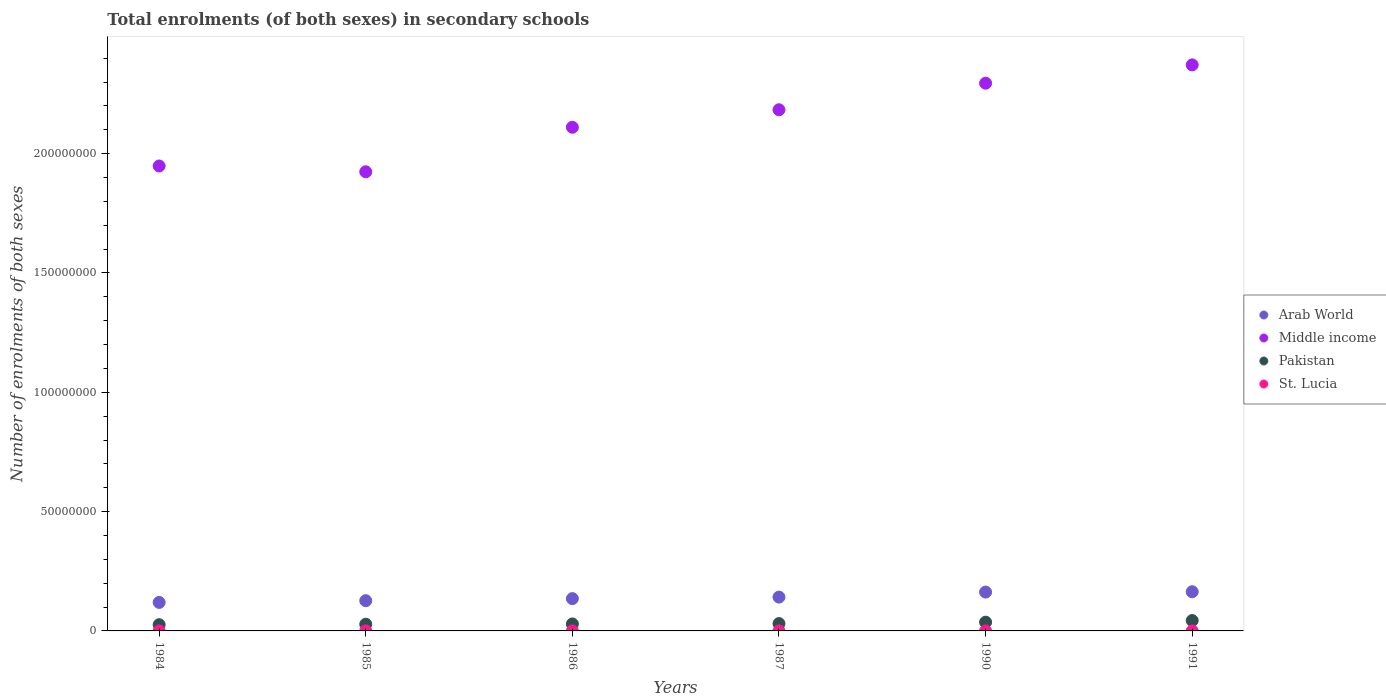What is the number of enrolments in secondary schools in Middle income in 1987?
Give a very brief answer. 2.18e+08. Across all years, what is the maximum number of enrolments in secondary schools in St. Lucia?
Give a very brief answer. 8230. Across all years, what is the minimum number of enrolments in secondary schools in St. Lucia?
Keep it short and to the point. 5205. In which year was the number of enrolments in secondary schools in St. Lucia minimum?
Offer a very short reply. 1984. What is the total number of enrolments in secondary schools in Pakistan in the graph?
Provide a succinct answer. 1.94e+07. What is the difference between the number of enrolments in secondary schools in Arab World in 1984 and that in 1991?
Make the answer very short. -4.48e+06. What is the difference between the number of enrolments in secondary schools in Middle income in 1985 and the number of enrolments in secondary schools in Arab World in 1986?
Your answer should be compact. 1.79e+08. What is the average number of enrolments in secondary schools in Arab World per year?
Your answer should be compact. 1.42e+07. In the year 1985, what is the difference between the number of enrolments in secondary schools in Arab World and number of enrolments in secondary schools in St. Lucia?
Your response must be concise. 1.27e+07. In how many years, is the number of enrolments in secondary schools in Pakistan greater than 90000000?
Give a very brief answer. 0. What is the ratio of the number of enrolments in secondary schools in Arab World in 1984 to that in 1986?
Keep it short and to the point. 0.88. What is the difference between the highest and the second highest number of enrolments in secondary schools in St. Lucia?
Offer a terse response. 428. What is the difference between the highest and the lowest number of enrolments in secondary schools in Middle income?
Your answer should be very brief. 4.48e+07. Is the number of enrolments in secondary schools in Middle income strictly less than the number of enrolments in secondary schools in Pakistan over the years?
Provide a short and direct response. No. How many dotlines are there?
Your answer should be very brief. 4. Are the values on the major ticks of Y-axis written in scientific E-notation?
Your answer should be very brief. No. Does the graph contain grids?
Ensure brevity in your answer.  No. Where does the legend appear in the graph?
Ensure brevity in your answer.  Center right. How many legend labels are there?
Provide a succinct answer. 4. What is the title of the graph?
Your answer should be compact. Total enrolments (of both sexes) in secondary schools. Does "Burkina Faso" appear as one of the legend labels in the graph?
Make the answer very short. No. What is the label or title of the X-axis?
Provide a short and direct response. Years. What is the label or title of the Y-axis?
Make the answer very short. Number of enrolments of both sexes. What is the Number of enrolments of both sexes in Arab World in 1984?
Provide a succinct answer. 1.19e+07. What is the Number of enrolments of both sexes of Middle income in 1984?
Provide a succinct answer. 1.95e+08. What is the Number of enrolments of both sexes of Pakistan in 1984?
Your response must be concise. 2.62e+06. What is the Number of enrolments of both sexes of St. Lucia in 1984?
Offer a very short reply. 5205. What is the Number of enrolments of both sexes of Arab World in 1985?
Provide a short and direct response. 1.27e+07. What is the Number of enrolments of both sexes of Middle income in 1985?
Offer a very short reply. 1.92e+08. What is the Number of enrolments of both sexes of Pakistan in 1985?
Offer a very short reply. 2.81e+06. What is the Number of enrolments of both sexes in St. Lucia in 1985?
Your answer should be very brief. 6212. What is the Number of enrolments of both sexes of Arab World in 1986?
Offer a terse response. 1.35e+07. What is the Number of enrolments of both sexes of Middle income in 1986?
Ensure brevity in your answer.  2.11e+08. What is the Number of enrolments of both sexes in Pakistan in 1986?
Your response must be concise. 2.92e+06. What is the Number of enrolments of both sexes of St. Lucia in 1986?
Ensure brevity in your answer.  6833. What is the Number of enrolments of both sexes in Arab World in 1987?
Make the answer very short. 1.42e+07. What is the Number of enrolments of both sexes of Middle income in 1987?
Keep it short and to the point. 2.18e+08. What is the Number of enrolments of both sexes in Pakistan in 1987?
Offer a very short reply. 3.07e+06. What is the Number of enrolments of both sexes of St. Lucia in 1987?
Your answer should be very brief. 7013. What is the Number of enrolments of both sexes of Arab World in 1990?
Offer a very short reply. 1.63e+07. What is the Number of enrolments of both sexes in Middle income in 1990?
Provide a short and direct response. 2.30e+08. What is the Number of enrolments of both sexes in Pakistan in 1990?
Give a very brief answer. 3.67e+06. What is the Number of enrolments of both sexes of St. Lucia in 1990?
Your answer should be very brief. 7802. What is the Number of enrolments of both sexes of Arab World in 1991?
Provide a succinct answer. 1.64e+07. What is the Number of enrolments of both sexes of Middle income in 1991?
Your answer should be compact. 2.37e+08. What is the Number of enrolments of both sexes of Pakistan in 1991?
Keep it short and to the point. 4.35e+06. What is the Number of enrolments of both sexes of St. Lucia in 1991?
Provide a succinct answer. 8230. Across all years, what is the maximum Number of enrolments of both sexes in Arab World?
Offer a terse response. 1.64e+07. Across all years, what is the maximum Number of enrolments of both sexes in Middle income?
Your answer should be very brief. 2.37e+08. Across all years, what is the maximum Number of enrolments of both sexes of Pakistan?
Your answer should be very brief. 4.35e+06. Across all years, what is the maximum Number of enrolments of both sexes in St. Lucia?
Your answer should be compact. 8230. Across all years, what is the minimum Number of enrolments of both sexes in Arab World?
Provide a short and direct response. 1.19e+07. Across all years, what is the minimum Number of enrolments of both sexes of Middle income?
Offer a very short reply. 1.92e+08. Across all years, what is the minimum Number of enrolments of both sexes of Pakistan?
Offer a very short reply. 2.62e+06. Across all years, what is the minimum Number of enrolments of both sexes of St. Lucia?
Provide a short and direct response. 5205. What is the total Number of enrolments of both sexes of Arab World in the graph?
Your answer should be very brief. 8.50e+07. What is the total Number of enrolments of both sexes of Middle income in the graph?
Give a very brief answer. 1.28e+09. What is the total Number of enrolments of both sexes of Pakistan in the graph?
Your answer should be very brief. 1.94e+07. What is the total Number of enrolments of both sexes of St. Lucia in the graph?
Offer a very short reply. 4.13e+04. What is the difference between the Number of enrolments of both sexes in Arab World in 1984 and that in 1985?
Your answer should be very brief. -7.28e+05. What is the difference between the Number of enrolments of both sexes in Middle income in 1984 and that in 1985?
Offer a very short reply. 2.43e+06. What is the difference between the Number of enrolments of both sexes in Pakistan in 1984 and that in 1985?
Provide a short and direct response. -1.96e+05. What is the difference between the Number of enrolments of both sexes in St. Lucia in 1984 and that in 1985?
Offer a very short reply. -1007. What is the difference between the Number of enrolments of both sexes in Arab World in 1984 and that in 1986?
Provide a succinct answer. -1.59e+06. What is the difference between the Number of enrolments of both sexes in Middle income in 1984 and that in 1986?
Keep it short and to the point. -1.62e+07. What is the difference between the Number of enrolments of both sexes in Pakistan in 1984 and that in 1986?
Ensure brevity in your answer.  -3.08e+05. What is the difference between the Number of enrolments of both sexes of St. Lucia in 1984 and that in 1986?
Offer a very short reply. -1628. What is the difference between the Number of enrolments of both sexes in Arab World in 1984 and that in 1987?
Keep it short and to the point. -2.23e+06. What is the difference between the Number of enrolments of both sexes of Middle income in 1984 and that in 1987?
Ensure brevity in your answer.  -2.36e+07. What is the difference between the Number of enrolments of both sexes in Pakistan in 1984 and that in 1987?
Your response must be concise. -4.56e+05. What is the difference between the Number of enrolments of both sexes in St. Lucia in 1984 and that in 1987?
Ensure brevity in your answer.  -1808. What is the difference between the Number of enrolments of both sexes in Arab World in 1984 and that in 1990?
Keep it short and to the point. -4.33e+06. What is the difference between the Number of enrolments of both sexes in Middle income in 1984 and that in 1990?
Make the answer very short. -3.47e+07. What is the difference between the Number of enrolments of both sexes of Pakistan in 1984 and that in 1990?
Offer a terse response. -1.05e+06. What is the difference between the Number of enrolments of both sexes in St. Lucia in 1984 and that in 1990?
Provide a short and direct response. -2597. What is the difference between the Number of enrolments of both sexes of Arab World in 1984 and that in 1991?
Provide a succinct answer. -4.48e+06. What is the difference between the Number of enrolments of both sexes of Middle income in 1984 and that in 1991?
Offer a very short reply. -4.24e+07. What is the difference between the Number of enrolments of both sexes of Pakistan in 1984 and that in 1991?
Ensure brevity in your answer.  -1.73e+06. What is the difference between the Number of enrolments of both sexes of St. Lucia in 1984 and that in 1991?
Provide a succinct answer. -3025. What is the difference between the Number of enrolments of both sexes in Arab World in 1985 and that in 1986?
Your answer should be compact. -8.65e+05. What is the difference between the Number of enrolments of both sexes of Middle income in 1985 and that in 1986?
Your answer should be very brief. -1.87e+07. What is the difference between the Number of enrolments of both sexes of Pakistan in 1985 and that in 1986?
Keep it short and to the point. -1.12e+05. What is the difference between the Number of enrolments of both sexes in St. Lucia in 1985 and that in 1986?
Your response must be concise. -621. What is the difference between the Number of enrolments of both sexes in Arab World in 1985 and that in 1987?
Your answer should be compact. -1.50e+06. What is the difference between the Number of enrolments of both sexes of Middle income in 1985 and that in 1987?
Give a very brief answer. -2.60e+07. What is the difference between the Number of enrolments of both sexes in Pakistan in 1985 and that in 1987?
Give a very brief answer. -2.59e+05. What is the difference between the Number of enrolments of both sexes in St. Lucia in 1985 and that in 1987?
Your response must be concise. -801. What is the difference between the Number of enrolments of both sexes of Arab World in 1985 and that in 1990?
Provide a succinct answer. -3.60e+06. What is the difference between the Number of enrolments of both sexes in Middle income in 1985 and that in 1990?
Provide a short and direct response. -3.71e+07. What is the difference between the Number of enrolments of both sexes in Pakistan in 1985 and that in 1990?
Provide a succinct answer. -8.54e+05. What is the difference between the Number of enrolments of both sexes in St. Lucia in 1985 and that in 1990?
Provide a succinct answer. -1590. What is the difference between the Number of enrolments of both sexes in Arab World in 1985 and that in 1991?
Give a very brief answer. -3.75e+06. What is the difference between the Number of enrolments of both sexes of Middle income in 1985 and that in 1991?
Keep it short and to the point. -4.48e+07. What is the difference between the Number of enrolments of both sexes in Pakistan in 1985 and that in 1991?
Offer a terse response. -1.53e+06. What is the difference between the Number of enrolments of both sexes of St. Lucia in 1985 and that in 1991?
Your answer should be very brief. -2018. What is the difference between the Number of enrolments of both sexes in Arab World in 1986 and that in 1987?
Offer a very short reply. -6.37e+05. What is the difference between the Number of enrolments of both sexes of Middle income in 1986 and that in 1987?
Offer a terse response. -7.33e+06. What is the difference between the Number of enrolments of both sexes of Pakistan in 1986 and that in 1987?
Your answer should be very brief. -1.48e+05. What is the difference between the Number of enrolments of both sexes in St. Lucia in 1986 and that in 1987?
Ensure brevity in your answer.  -180. What is the difference between the Number of enrolments of both sexes in Arab World in 1986 and that in 1990?
Ensure brevity in your answer.  -2.74e+06. What is the difference between the Number of enrolments of both sexes of Middle income in 1986 and that in 1990?
Your answer should be compact. -1.85e+07. What is the difference between the Number of enrolments of both sexes of Pakistan in 1986 and that in 1990?
Provide a succinct answer. -7.42e+05. What is the difference between the Number of enrolments of both sexes of St. Lucia in 1986 and that in 1990?
Your answer should be compact. -969. What is the difference between the Number of enrolments of both sexes of Arab World in 1986 and that in 1991?
Your answer should be compact. -2.88e+06. What is the difference between the Number of enrolments of both sexes in Middle income in 1986 and that in 1991?
Keep it short and to the point. -2.61e+07. What is the difference between the Number of enrolments of both sexes in Pakistan in 1986 and that in 1991?
Provide a succinct answer. -1.42e+06. What is the difference between the Number of enrolments of both sexes in St. Lucia in 1986 and that in 1991?
Your answer should be compact. -1397. What is the difference between the Number of enrolments of both sexes of Arab World in 1987 and that in 1990?
Provide a short and direct response. -2.10e+06. What is the difference between the Number of enrolments of both sexes of Middle income in 1987 and that in 1990?
Your answer should be compact. -1.11e+07. What is the difference between the Number of enrolments of both sexes in Pakistan in 1987 and that in 1990?
Provide a succinct answer. -5.94e+05. What is the difference between the Number of enrolments of both sexes in St. Lucia in 1987 and that in 1990?
Keep it short and to the point. -789. What is the difference between the Number of enrolments of both sexes of Arab World in 1987 and that in 1991?
Keep it short and to the point. -2.25e+06. What is the difference between the Number of enrolments of both sexes in Middle income in 1987 and that in 1991?
Make the answer very short. -1.88e+07. What is the difference between the Number of enrolments of both sexes in Pakistan in 1987 and that in 1991?
Your response must be concise. -1.27e+06. What is the difference between the Number of enrolments of both sexes in St. Lucia in 1987 and that in 1991?
Provide a short and direct response. -1217. What is the difference between the Number of enrolments of both sexes of Arab World in 1990 and that in 1991?
Give a very brief answer. -1.43e+05. What is the difference between the Number of enrolments of both sexes of Middle income in 1990 and that in 1991?
Offer a very short reply. -7.67e+06. What is the difference between the Number of enrolments of both sexes in Pakistan in 1990 and that in 1991?
Provide a succinct answer. -6.80e+05. What is the difference between the Number of enrolments of both sexes in St. Lucia in 1990 and that in 1991?
Provide a short and direct response. -428. What is the difference between the Number of enrolments of both sexes of Arab World in 1984 and the Number of enrolments of both sexes of Middle income in 1985?
Make the answer very short. -1.80e+08. What is the difference between the Number of enrolments of both sexes of Arab World in 1984 and the Number of enrolments of both sexes of Pakistan in 1985?
Your answer should be compact. 9.13e+06. What is the difference between the Number of enrolments of both sexes in Arab World in 1984 and the Number of enrolments of both sexes in St. Lucia in 1985?
Keep it short and to the point. 1.19e+07. What is the difference between the Number of enrolments of both sexes of Middle income in 1984 and the Number of enrolments of both sexes of Pakistan in 1985?
Offer a very short reply. 1.92e+08. What is the difference between the Number of enrolments of both sexes of Middle income in 1984 and the Number of enrolments of both sexes of St. Lucia in 1985?
Offer a very short reply. 1.95e+08. What is the difference between the Number of enrolments of both sexes in Pakistan in 1984 and the Number of enrolments of both sexes in St. Lucia in 1985?
Your response must be concise. 2.61e+06. What is the difference between the Number of enrolments of both sexes of Arab World in 1984 and the Number of enrolments of both sexes of Middle income in 1986?
Ensure brevity in your answer.  -1.99e+08. What is the difference between the Number of enrolments of both sexes in Arab World in 1984 and the Number of enrolments of both sexes in Pakistan in 1986?
Give a very brief answer. 9.02e+06. What is the difference between the Number of enrolments of both sexes of Arab World in 1984 and the Number of enrolments of both sexes of St. Lucia in 1986?
Make the answer very short. 1.19e+07. What is the difference between the Number of enrolments of both sexes in Middle income in 1984 and the Number of enrolments of both sexes in Pakistan in 1986?
Provide a succinct answer. 1.92e+08. What is the difference between the Number of enrolments of both sexes of Middle income in 1984 and the Number of enrolments of both sexes of St. Lucia in 1986?
Offer a terse response. 1.95e+08. What is the difference between the Number of enrolments of both sexes in Pakistan in 1984 and the Number of enrolments of both sexes in St. Lucia in 1986?
Keep it short and to the point. 2.61e+06. What is the difference between the Number of enrolments of both sexes of Arab World in 1984 and the Number of enrolments of both sexes of Middle income in 1987?
Offer a very short reply. -2.06e+08. What is the difference between the Number of enrolments of both sexes in Arab World in 1984 and the Number of enrolments of both sexes in Pakistan in 1987?
Ensure brevity in your answer.  8.87e+06. What is the difference between the Number of enrolments of both sexes of Arab World in 1984 and the Number of enrolments of both sexes of St. Lucia in 1987?
Provide a short and direct response. 1.19e+07. What is the difference between the Number of enrolments of both sexes of Middle income in 1984 and the Number of enrolments of both sexes of Pakistan in 1987?
Provide a short and direct response. 1.92e+08. What is the difference between the Number of enrolments of both sexes of Middle income in 1984 and the Number of enrolments of both sexes of St. Lucia in 1987?
Make the answer very short. 1.95e+08. What is the difference between the Number of enrolments of both sexes of Pakistan in 1984 and the Number of enrolments of both sexes of St. Lucia in 1987?
Provide a succinct answer. 2.61e+06. What is the difference between the Number of enrolments of both sexes in Arab World in 1984 and the Number of enrolments of both sexes in Middle income in 1990?
Make the answer very short. -2.18e+08. What is the difference between the Number of enrolments of both sexes of Arab World in 1984 and the Number of enrolments of both sexes of Pakistan in 1990?
Provide a short and direct response. 8.28e+06. What is the difference between the Number of enrolments of both sexes in Arab World in 1984 and the Number of enrolments of both sexes in St. Lucia in 1990?
Ensure brevity in your answer.  1.19e+07. What is the difference between the Number of enrolments of both sexes in Middle income in 1984 and the Number of enrolments of both sexes in Pakistan in 1990?
Offer a very short reply. 1.91e+08. What is the difference between the Number of enrolments of both sexes in Middle income in 1984 and the Number of enrolments of both sexes in St. Lucia in 1990?
Your response must be concise. 1.95e+08. What is the difference between the Number of enrolments of both sexes in Pakistan in 1984 and the Number of enrolments of both sexes in St. Lucia in 1990?
Ensure brevity in your answer.  2.61e+06. What is the difference between the Number of enrolments of both sexes in Arab World in 1984 and the Number of enrolments of both sexes in Middle income in 1991?
Make the answer very short. -2.25e+08. What is the difference between the Number of enrolments of both sexes in Arab World in 1984 and the Number of enrolments of both sexes in Pakistan in 1991?
Offer a very short reply. 7.60e+06. What is the difference between the Number of enrolments of both sexes of Arab World in 1984 and the Number of enrolments of both sexes of St. Lucia in 1991?
Provide a succinct answer. 1.19e+07. What is the difference between the Number of enrolments of both sexes of Middle income in 1984 and the Number of enrolments of both sexes of Pakistan in 1991?
Offer a terse response. 1.90e+08. What is the difference between the Number of enrolments of both sexes of Middle income in 1984 and the Number of enrolments of both sexes of St. Lucia in 1991?
Offer a very short reply. 1.95e+08. What is the difference between the Number of enrolments of both sexes of Pakistan in 1984 and the Number of enrolments of both sexes of St. Lucia in 1991?
Offer a terse response. 2.61e+06. What is the difference between the Number of enrolments of both sexes in Arab World in 1985 and the Number of enrolments of both sexes in Middle income in 1986?
Your answer should be very brief. -1.98e+08. What is the difference between the Number of enrolments of both sexes in Arab World in 1985 and the Number of enrolments of both sexes in Pakistan in 1986?
Provide a succinct answer. 9.75e+06. What is the difference between the Number of enrolments of both sexes in Arab World in 1985 and the Number of enrolments of both sexes in St. Lucia in 1986?
Give a very brief answer. 1.27e+07. What is the difference between the Number of enrolments of both sexes in Middle income in 1985 and the Number of enrolments of both sexes in Pakistan in 1986?
Your response must be concise. 1.89e+08. What is the difference between the Number of enrolments of both sexes in Middle income in 1985 and the Number of enrolments of both sexes in St. Lucia in 1986?
Your answer should be compact. 1.92e+08. What is the difference between the Number of enrolments of both sexes in Pakistan in 1985 and the Number of enrolments of both sexes in St. Lucia in 1986?
Provide a succinct answer. 2.80e+06. What is the difference between the Number of enrolments of both sexes in Arab World in 1985 and the Number of enrolments of both sexes in Middle income in 1987?
Keep it short and to the point. -2.06e+08. What is the difference between the Number of enrolments of both sexes in Arab World in 1985 and the Number of enrolments of both sexes in Pakistan in 1987?
Give a very brief answer. 9.60e+06. What is the difference between the Number of enrolments of both sexes of Arab World in 1985 and the Number of enrolments of both sexes of St. Lucia in 1987?
Ensure brevity in your answer.  1.27e+07. What is the difference between the Number of enrolments of both sexes in Middle income in 1985 and the Number of enrolments of both sexes in Pakistan in 1987?
Your answer should be very brief. 1.89e+08. What is the difference between the Number of enrolments of both sexes of Middle income in 1985 and the Number of enrolments of both sexes of St. Lucia in 1987?
Make the answer very short. 1.92e+08. What is the difference between the Number of enrolments of both sexes in Pakistan in 1985 and the Number of enrolments of both sexes in St. Lucia in 1987?
Your answer should be compact. 2.80e+06. What is the difference between the Number of enrolments of both sexes of Arab World in 1985 and the Number of enrolments of both sexes of Middle income in 1990?
Keep it short and to the point. -2.17e+08. What is the difference between the Number of enrolments of both sexes of Arab World in 1985 and the Number of enrolments of both sexes of Pakistan in 1990?
Provide a short and direct response. 9.01e+06. What is the difference between the Number of enrolments of both sexes of Arab World in 1985 and the Number of enrolments of both sexes of St. Lucia in 1990?
Provide a succinct answer. 1.27e+07. What is the difference between the Number of enrolments of both sexes of Middle income in 1985 and the Number of enrolments of both sexes of Pakistan in 1990?
Your response must be concise. 1.89e+08. What is the difference between the Number of enrolments of both sexes of Middle income in 1985 and the Number of enrolments of both sexes of St. Lucia in 1990?
Provide a succinct answer. 1.92e+08. What is the difference between the Number of enrolments of both sexes of Pakistan in 1985 and the Number of enrolments of both sexes of St. Lucia in 1990?
Give a very brief answer. 2.80e+06. What is the difference between the Number of enrolments of both sexes of Arab World in 1985 and the Number of enrolments of both sexes of Middle income in 1991?
Provide a succinct answer. -2.25e+08. What is the difference between the Number of enrolments of both sexes of Arab World in 1985 and the Number of enrolments of both sexes of Pakistan in 1991?
Your answer should be compact. 8.33e+06. What is the difference between the Number of enrolments of both sexes in Arab World in 1985 and the Number of enrolments of both sexes in St. Lucia in 1991?
Your answer should be compact. 1.27e+07. What is the difference between the Number of enrolments of both sexes of Middle income in 1985 and the Number of enrolments of both sexes of Pakistan in 1991?
Offer a terse response. 1.88e+08. What is the difference between the Number of enrolments of both sexes of Middle income in 1985 and the Number of enrolments of both sexes of St. Lucia in 1991?
Offer a terse response. 1.92e+08. What is the difference between the Number of enrolments of both sexes in Pakistan in 1985 and the Number of enrolments of both sexes in St. Lucia in 1991?
Your answer should be compact. 2.80e+06. What is the difference between the Number of enrolments of both sexes in Arab World in 1986 and the Number of enrolments of both sexes in Middle income in 1987?
Make the answer very short. -2.05e+08. What is the difference between the Number of enrolments of both sexes in Arab World in 1986 and the Number of enrolments of both sexes in Pakistan in 1987?
Give a very brief answer. 1.05e+07. What is the difference between the Number of enrolments of both sexes of Arab World in 1986 and the Number of enrolments of both sexes of St. Lucia in 1987?
Your answer should be compact. 1.35e+07. What is the difference between the Number of enrolments of both sexes of Middle income in 1986 and the Number of enrolments of both sexes of Pakistan in 1987?
Your answer should be compact. 2.08e+08. What is the difference between the Number of enrolments of both sexes of Middle income in 1986 and the Number of enrolments of both sexes of St. Lucia in 1987?
Make the answer very short. 2.11e+08. What is the difference between the Number of enrolments of both sexes of Pakistan in 1986 and the Number of enrolments of both sexes of St. Lucia in 1987?
Ensure brevity in your answer.  2.92e+06. What is the difference between the Number of enrolments of both sexes of Arab World in 1986 and the Number of enrolments of both sexes of Middle income in 1990?
Ensure brevity in your answer.  -2.16e+08. What is the difference between the Number of enrolments of both sexes of Arab World in 1986 and the Number of enrolments of both sexes of Pakistan in 1990?
Your response must be concise. 9.87e+06. What is the difference between the Number of enrolments of both sexes of Arab World in 1986 and the Number of enrolments of both sexes of St. Lucia in 1990?
Your answer should be compact. 1.35e+07. What is the difference between the Number of enrolments of both sexes in Middle income in 1986 and the Number of enrolments of both sexes in Pakistan in 1990?
Your response must be concise. 2.07e+08. What is the difference between the Number of enrolments of both sexes of Middle income in 1986 and the Number of enrolments of both sexes of St. Lucia in 1990?
Provide a succinct answer. 2.11e+08. What is the difference between the Number of enrolments of both sexes of Pakistan in 1986 and the Number of enrolments of both sexes of St. Lucia in 1990?
Offer a very short reply. 2.92e+06. What is the difference between the Number of enrolments of both sexes of Arab World in 1986 and the Number of enrolments of both sexes of Middle income in 1991?
Your response must be concise. -2.24e+08. What is the difference between the Number of enrolments of both sexes in Arab World in 1986 and the Number of enrolments of both sexes in Pakistan in 1991?
Ensure brevity in your answer.  9.19e+06. What is the difference between the Number of enrolments of both sexes in Arab World in 1986 and the Number of enrolments of both sexes in St. Lucia in 1991?
Provide a succinct answer. 1.35e+07. What is the difference between the Number of enrolments of both sexes of Middle income in 1986 and the Number of enrolments of both sexes of Pakistan in 1991?
Your answer should be compact. 2.07e+08. What is the difference between the Number of enrolments of both sexes in Middle income in 1986 and the Number of enrolments of both sexes in St. Lucia in 1991?
Keep it short and to the point. 2.11e+08. What is the difference between the Number of enrolments of both sexes in Pakistan in 1986 and the Number of enrolments of both sexes in St. Lucia in 1991?
Offer a terse response. 2.91e+06. What is the difference between the Number of enrolments of both sexes in Arab World in 1987 and the Number of enrolments of both sexes in Middle income in 1990?
Give a very brief answer. -2.15e+08. What is the difference between the Number of enrolments of both sexes in Arab World in 1987 and the Number of enrolments of both sexes in Pakistan in 1990?
Make the answer very short. 1.05e+07. What is the difference between the Number of enrolments of both sexes in Arab World in 1987 and the Number of enrolments of both sexes in St. Lucia in 1990?
Offer a terse response. 1.42e+07. What is the difference between the Number of enrolments of both sexes of Middle income in 1987 and the Number of enrolments of both sexes of Pakistan in 1990?
Your response must be concise. 2.15e+08. What is the difference between the Number of enrolments of both sexes of Middle income in 1987 and the Number of enrolments of both sexes of St. Lucia in 1990?
Offer a terse response. 2.18e+08. What is the difference between the Number of enrolments of both sexes of Pakistan in 1987 and the Number of enrolments of both sexes of St. Lucia in 1990?
Make the answer very short. 3.06e+06. What is the difference between the Number of enrolments of both sexes of Arab World in 1987 and the Number of enrolments of both sexes of Middle income in 1991?
Provide a succinct answer. -2.23e+08. What is the difference between the Number of enrolments of both sexes of Arab World in 1987 and the Number of enrolments of both sexes of Pakistan in 1991?
Give a very brief answer. 9.83e+06. What is the difference between the Number of enrolments of both sexes of Arab World in 1987 and the Number of enrolments of both sexes of St. Lucia in 1991?
Your answer should be very brief. 1.42e+07. What is the difference between the Number of enrolments of both sexes in Middle income in 1987 and the Number of enrolments of both sexes in Pakistan in 1991?
Keep it short and to the point. 2.14e+08. What is the difference between the Number of enrolments of both sexes in Middle income in 1987 and the Number of enrolments of both sexes in St. Lucia in 1991?
Provide a succinct answer. 2.18e+08. What is the difference between the Number of enrolments of both sexes in Pakistan in 1987 and the Number of enrolments of both sexes in St. Lucia in 1991?
Give a very brief answer. 3.06e+06. What is the difference between the Number of enrolments of both sexes of Arab World in 1990 and the Number of enrolments of both sexes of Middle income in 1991?
Make the answer very short. -2.21e+08. What is the difference between the Number of enrolments of both sexes in Arab World in 1990 and the Number of enrolments of both sexes in Pakistan in 1991?
Provide a short and direct response. 1.19e+07. What is the difference between the Number of enrolments of both sexes of Arab World in 1990 and the Number of enrolments of both sexes of St. Lucia in 1991?
Offer a very short reply. 1.63e+07. What is the difference between the Number of enrolments of both sexes of Middle income in 1990 and the Number of enrolments of both sexes of Pakistan in 1991?
Offer a very short reply. 2.25e+08. What is the difference between the Number of enrolments of both sexes of Middle income in 1990 and the Number of enrolments of both sexes of St. Lucia in 1991?
Offer a terse response. 2.30e+08. What is the difference between the Number of enrolments of both sexes in Pakistan in 1990 and the Number of enrolments of both sexes in St. Lucia in 1991?
Make the answer very short. 3.66e+06. What is the average Number of enrolments of both sexes in Arab World per year?
Ensure brevity in your answer.  1.42e+07. What is the average Number of enrolments of both sexes of Middle income per year?
Provide a short and direct response. 2.14e+08. What is the average Number of enrolments of both sexes in Pakistan per year?
Make the answer very short. 3.24e+06. What is the average Number of enrolments of both sexes in St. Lucia per year?
Give a very brief answer. 6882.5. In the year 1984, what is the difference between the Number of enrolments of both sexes of Arab World and Number of enrolments of both sexes of Middle income?
Provide a short and direct response. -1.83e+08. In the year 1984, what is the difference between the Number of enrolments of both sexes in Arab World and Number of enrolments of both sexes in Pakistan?
Provide a succinct answer. 9.33e+06. In the year 1984, what is the difference between the Number of enrolments of both sexes in Arab World and Number of enrolments of both sexes in St. Lucia?
Offer a terse response. 1.19e+07. In the year 1984, what is the difference between the Number of enrolments of both sexes of Middle income and Number of enrolments of both sexes of Pakistan?
Provide a short and direct response. 1.92e+08. In the year 1984, what is the difference between the Number of enrolments of both sexes of Middle income and Number of enrolments of both sexes of St. Lucia?
Provide a succinct answer. 1.95e+08. In the year 1984, what is the difference between the Number of enrolments of both sexes of Pakistan and Number of enrolments of both sexes of St. Lucia?
Your answer should be compact. 2.61e+06. In the year 1985, what is the difference between the Number of enrolments of both sexes in Arab World and Number of enrolments of both sexes in Middle income?
Provide a succinct answer. -1.80e+08. In the year 1985, what is the difference between the Number of enrolments of both sexes in Arab World and Number of enrolments of both sexes in Pakistan?
Offer a very short reply. 9.86e+06. In the year 1985, what is the difference between the Number of enrolments of both sexes in Arab World and Number of enrolments of both sexes in St. Lucia?
Your answer should be very brief. 1.27e+07. In the year 1985, what is the difference between the Number of enrolments of both sexes in Middle income and Number of enrolments of both sexes in Pakistan?
Your response must be concise. 1.90e+08. In the year 1985, what is the difference between the Number of enrolments of both sexes in Middle income and Number of enrolments of both sexes in St. Lucia?
Provide a succinct answer. 1.92e+08. In the year 1985, what is the difference between the Number of enrolments of both sexes in Pakistan and Number of enrolments of both sexes in St. Lucia?
Give a very brief answer. 2.81e+06. In the year 1986, what is the difference between the Number of enrolments of both sexes in Arab World and Number of enrolments of both sexes in Middle income?
Offer a terse response. -1.98e+08. In the year 1986, what is the difference between the Number of enrolments of both sexes in Arab World and Number of enrolments of both sexes in Pakistan?
Provide a short and direct response. 1.06e+07. In the year 1986, what is the difference between the Number of enrolments of both sexes in Arab World and Number of enrolments of both sexes in St. Lucia?
Offer a terse response. 1.35e+07. In the year 1986, what is the difference between the Number of enrolments of both sexes of Middle income and Number of enrolments of both sexes of Pakistan?
Give a very brief answer. 2.08e+08. In the year 1986, what is the difference between the Number of enrolments of both sexes in Middle income and Number of enrolments of both sexes in St. Lucia?
Keep it short and to the point. 2.11e+08. In the year 1986, what is the difference between the Number of enrolments of both sexes of Pakistan and Number of enrolments of both sexes of St. Lucia?
Your response must be concise. 2.92e+06. In the year 1987, what is the difference between the Number of enrolments of both sexes of Arab World and Number of enrolments of both sexes of Middle income?
Provide a short and direct response. -2.04e+08. In the year 1987, what is the difference between the Number of enrolments of both sexes of Arab World and Number of enrolments of both sexes of Pakistan?
Make the answer very short. 1.11e+07. In the year 1987, what is the difference between the Number of enrolments of both sexes of Arab World and Number of enrolments of both sexes of St. Lucia?
Your answer should be compact. 1.42e+07. In the year 1987, what is the difference between the Number of enrolments of both sexes of Middle income and Number of enrolments of both sexes of Pakistan?
Your answer should be very brief. 2.15e+08. In the year 1987, what is the difference between the Number of enrolments of both sexes in Middle income and Number of enrolments of both sexes in St. Lucia?
Ensure brevity in your answer.  2.18e+08. In the year 1987, what is the difference between the Number of enrolments of both sexes in Pakistan and Number of enrolments of both sexes in St. Lucia?
Offer a terse response. 3.06e+06. In the year 1990, what is the difference between the Number of enrolments of both sexes in Arab World and Number of enrolments of both sexes in Middle income?
Your response must be concise. -2.13e+08. In the year 1990, what is the difference between the Number of enrolments of both sexes of Arab World and Number of enrolments of both sexes of Pakistan?
Your answer should be compact. 1.26e+07. In the year 1990, what is the difference between the Number of enrolments of both sexes in Arab World and Number of enrolments of both sexes in St. Lucia?
Give a very brief answer. 1.63e+07. In the year 1990, what is the difference between the Number of enrolments of both sexes in Middle income and Number of enrolments of both sexes in Pakistan?
Offer a terse response. 2.26e+08. In the year 1990, what is the difference between the Number of enrolments of both sexes in Middle income and Number of enrolments of both sexes in St. Lucia?
Your answer should be very brief. 2.30e+08. In the year 1990, what is the difference between the Number of enrolments of both sexes in Pakistan and Number of enrolments of both sexes in St. Lucia?
Provide a succinct answer. 3.66e+06. In the year 1991, what is the difference between the Number of enrolments of both sexes in Arab World and Number of enrolments of both sexes in Middle income?
Make the answer very short. -2.21e+08. In the year 1991, what is the difference between the Number of enrolments of both sexes in Arab World and Number of enrolments of both sexes in Pakistan?
Your response must be concise. 1.21e+07. In the year 1991, what is the difference between the Number of enrolments of both sexes of Arab World and Number of enrolments of both sexes of St. Lucia?
Provide a short and direct response. 1.64e+07. In the year 1991, what is the difference between the Number of enrolments of both sexes in Middle income and Number of enrolments of both sexes in Pakistan?
Give a very brief answer. 2.33e+08. In the year 1991, what is the difference between the Number of enrolments of both sexes of Middle income and Number of enrolments of both sexes of St. Lucia?
Provide a succinct answer. 2.37e+08. In the year 1991, what is the difference between the Number of enrolments of both sexes of Pakistan and Number of enrolments of both sexes of St. Lucia?
Your answer should be compact. 4.34e+06. What is the ratio of the Number of enrolments of both sexes of Arab World in 1984 to that in 1985?
Provide a succinct answer. 0.94. What is the ratio of the Number of enrolments of both sexes of Middle income in 1984 to that in 1985?
Offer a very short reply. 1.01. What is the ratio of the Number of enrolments of both sexes in Pakistan in 1984 to that in 1985?
Your answer should be very brief. 0.93. What is the ratio of the Number of enrolments of both sexes of St. Lucia in 1984 to that in 1985?
Provide a short and direct response. 0.84. What is the ratio of the Number of enrolments of both sexes of Arab World in 1984 to that in 1986?
Provide a short and direct response. 0.88. What is the ratio of the Number of enrolments of both sexes in Middle income in 1984 to that in 1986?
Provide a short and direct response. 0.92. What is the ratio of the Number of enrolments of both sexes of Pakistan in 1984 to that in 1986?
Give a very brief answer. 0.89. What is the ratio of the Number of enrolments of both sexes in St. Lucia in 1984 to that in 1986?
Your response must be concise. 0.76. What is the ratio of the Number of enrolments of both sexes in Arab World in 1984 to that in 1987?
Your response must be concise. 0.84. What is the ratio of the Number of enrolments of both sexes in Middle income in 1984 to that in 1987?
Give a very brief answer. 0.89. What is the ratio of the Number of enrolments of both sexes in Pakistan in 1984 to that in 1987?
Provide a succinct answer. 0.85. What is the ratio of the Number of enrolments of both sexes of St. Lucia in 1984 to that in 1987?
Your answer should be compact. 0.74. What is the ratio of the Number of enrolments of both sexes in Arab World in 1984 to that in 1990?
Your answer should be very brief. 0.73. What is the ratio of the Number of enrolments of both sexes of Middle income in 1984 to that in 1990?
Provide a short and direct response. 0.85. What is the ratio of the Number of enrolments of both sexes of Pakistan in 1984 to that in 1990?
Offer a terse response. 0.71. What is the ratio of the Number of enrolments of both sexes of St. Lucia in 1984 to that in 1990?
Your answer should be very brief. 0.67. What is the ratio of the Number of enrolments of both sexes in Arab World in 1984 to that in 1991?
Ensure brevity in your answer.  0.73. What is the ratio of the Number of enrolments of both sexes in Middle income in 1984 to that in 1991?
Your answer should be compact. 0.82. What is the ratio of the Number of enrolments of both sexes in Pakistan in 1984 to that in 1991?
Provide a short and direct response. 0.6. What is the ratio of the Number of enrolments of both sexes in St. Lucia in 1984 to that in 1991?
Your answer should be compact. 0.63. What is the ratio of the Number of enrolments of both sexes in Arab World in 1985 to that in 1986?
Provide a short and direct response. 0.94. What is the ratio of the Number of enrolments of both sexes in Middle income in 1985 to that in 1986?
Your response must be concise. 0.91. What is the ratio of the Number of enrolments of both sexes of Pakistan in 1985 to that in 1986?
Your response must be concise. 0.96. What is the ratio of the Number of enrolments of both sexes in St. Lucia in 1985 to that in 1986?
Ensure brevity in your answer.  0.91. What is the ratio of the Number of enrolments of both sexes in Arab World in 1985 to that in 1987?
Provide a short and direct response. 0.89. What is the ratio of the Number of enrolments of both sexes of Middle income in 1985 to that in 1987?
Provide a short and direct response. 0.88. What is the ratio of the Number of enrolments of both sexes of Pakistan in 1985 to that in 1987?
Provide a succinct answer. 0.92. What is the ratio of the Number of enrolments of both sexes of St. Lucia in 1985 to that in 1987?
Ensure brevity in your answer.  0.89. What is the ratio of the Number of enrolments of both sexes of Arab World in 1985 to that in 1990?
Keep it short and to the point. 0.78. What is the ratio of the Number of enrolments of both sexes of Middle income in 1985 to that in 1990?
Offer a very short reply. 0.84. What is the ratio of the Number of enrolments of both sexes in Pakistan in 1985 to that in 1990?
Offer a terse response. 0.77. What is the ratio of the Number of enrolments of both sexes of St. Lucia in 1985 to that in 1990?
Your response must be concise. 0.8. What is the ratio of the Number of enrolments of both sexes of Arab World in 1985 to that in 1991?
Make the answer very short. 0.77. What is the ratio of the Number of enrolments of both sexes in Middle income in 1985 to that in 1991?
Your answer should be very brief. 0.81. What is the ratio of the Number of enrolments of both sexes in Pakistan in 1985 to that in 1991?
Offer a terse response. 0.65. What is the ratio of the Number of enrolments of both sexes in St. Lucia in 1985 to that in 1991?
Your answer should be compact. 0.75. What is the ratio of the Number of enrolments of both sexes of Arab World in 1986 to that in 1987?
Ensure brevity in your answer.  0.96. What is the ratio of the Number of enrolments of both sexes of Middle income in 1986 to that in 1987?
Provide a short and direct response. 0.97. What is the ratio of the Number of enrolments of both sexes in Pakistan in 1986 to that in 1987?
Provide a succinct answer. 0.95. What is the ratio of the Number of enrolments of both sexes of St. Lucia in 1986 to that in 1987?
Make the answer very short. 0.97. What is the ratio of the Number of enrolments of both sexes of Arab World in 1986 to that in 1990?
Offer a terse response. 0.83. What is the ratio of the Number of enrolments of both sexes of Middle income in 1986 to that in 1990?
Your answer should be compact. 0.92. What is the ratio of the Number of enrolments of both sexes of Pakistan in 1986 to that in 1990?
Give a very brief answer. 0.8. What is the ratio of the Number of enrolments of both sexes of St. Lucia in 1986 to that in 1990?
Your answer should be very brief. 0.88. What is the ratio of the Number of enrolments of both sexes of Arab World in 1986 to that in 1991?
Provide a succinct answer. 0.82. What is the ratio of the Number of enrolments of both sexes in Middle income in 1986 to that in 1991?
Offer a very short reply. 0.89. What is the ratio of the Number of enrolments of both sexes of Pakistan in 1986 to that in 1991?
Your answer should be compact. 0.67. What is the ratio of the Number of enrolments of both sexes in St. Lucia in 1986 to that in 1991?
Offer a very short reply. 0.83. What is the ratio of the Number of enrolments of both sexes in Arab World in 1987 to that in 1990?
Ensure brevity in your answer.  0.87. What is the ratio of the Number of enrolments of both sexes of Middle income in 1987 to that in 1990?
Make the answer very short. 0.95. What is the ratio of the Number of enrolments of both sexes in Pakistan in 1987 to that in 1990?
Provide a short and direct response. 0.84. What is the ratio of the Number of enrolments of both sexes of St. Lucia in 1987 to that in 1990?
Offer a terse response. 0.9. What is the ratio of the Number of enrolments of both sexes in Arab World in 1987 to that in 1991?
Your answer should be very brief. 0.86. What is the ratio of the Number of enrolments of both sexes in Middle income in 1987 to that in 1991?
Provide a succinct answer. 0.92. What is the ratio of the Number of enrolments of both sexes in Pakistan in 1987 to that in 1991?
Provide a short and direct response. 0.71. What is the ratio of the Number of enrolments of both sexes of St. Lucia in 1987 to that in 1991?
Ensure brevity in your answer.  0.85. What is the ratio of the Number of enrolments of both sexes in Arab World in 1990 to that in 1991?
Give a very brief answer. 0.99. What is the ratio of the Number of enrolments of both sexes of Middle income in 1990 to that in 1991?
Provide a succinct answer. 0.97. What is the ratio of the Number of enrolments of both sexes in Pakistan in 1990 to that in 1991?
Offer a very short reply. 0.84. What is the ratio of the Number of enrolments of both sexes of St. Lucia in 1990 to that in 1991?
Offer a terse response. 0.95. What is the difference between the highest and the second highest Number of enrolments of both sexes in Arab World?
Offer a terse response. 1.43e+05. What is the difference between the highest and the second highest Number of enrolments of both sexes in Middle income?
Provide a short and direct response. 7.67e+06. What is the difference between the highest and the second highest Number of enrolments of both sexes of Pakistan?
Offer a terse response. 6.80e+05. What is the difference between the highest and the second highest Number of enrolments of both sexes of St. Lucia?
Offer a very short reply. 428. What is the difference between the highest and the lowest Number of enrolments of both sexes in Arab World?
Provide a succinct answer. 4.48e+06. What is the difference between the highest and the lowest Number of enrolments of both sexes of Middle income?
Your response must be concise. 4.48e+07. What is the difference between the highest and the lowest Number of enrolments of both sexes of Pakistan?
Make the answer very short. 1.73e+06. What is the difference between the highest and the lowest Number of enrolments of both sexes in St. Lucia?
Make the answer very short. 3025. 